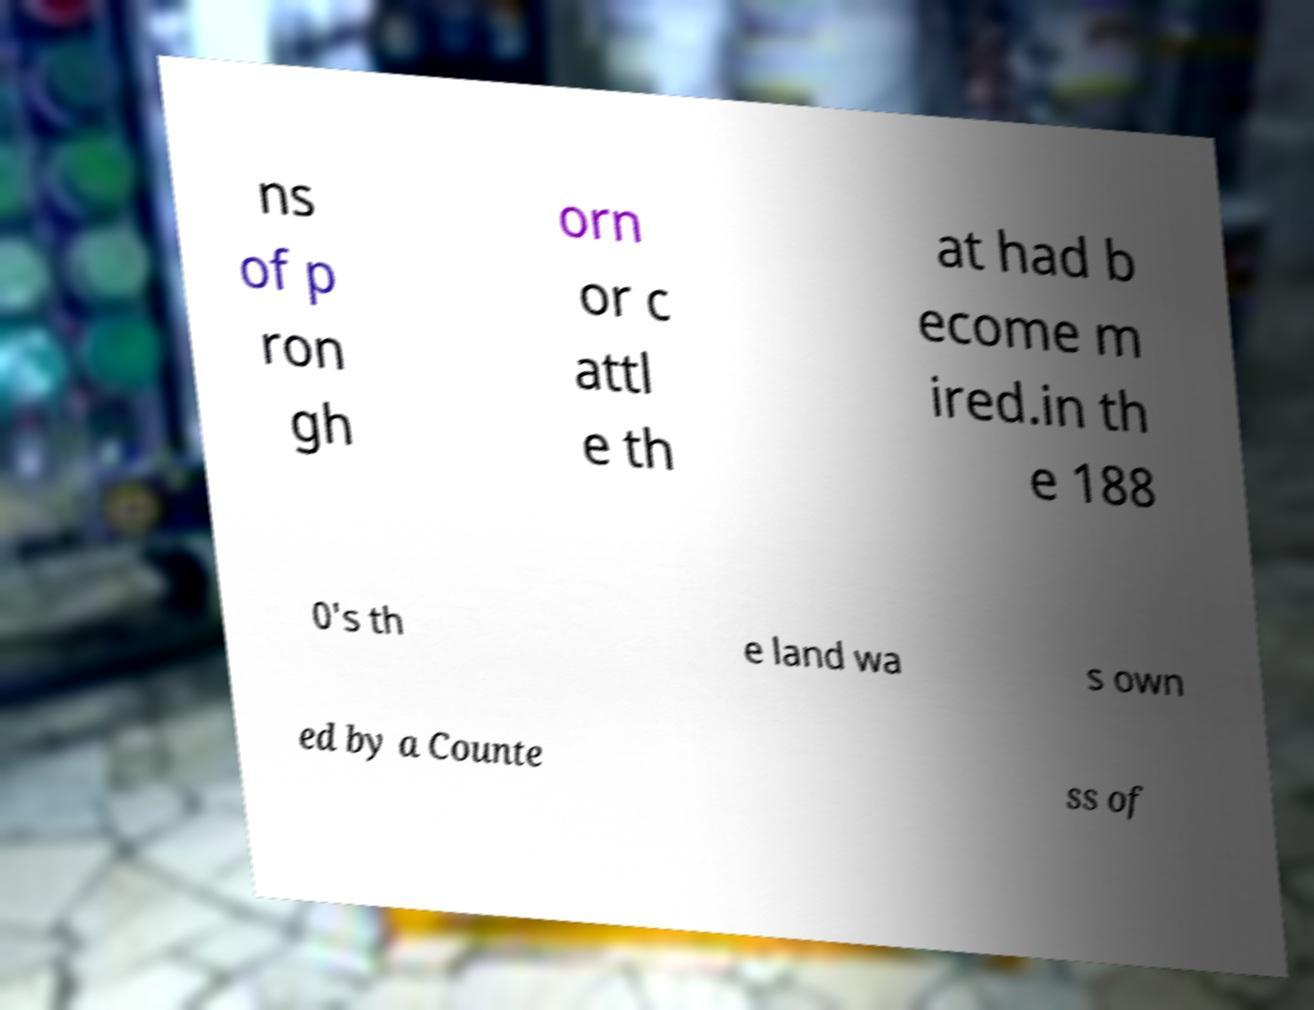There's text embedded in this image that I need extracted. Can you transcribe it verbatim? ns of p ron gh orn or c attl e th at had b ecome m ired.in th e 188 0's th e land wa s own ed by a Counte ss of 